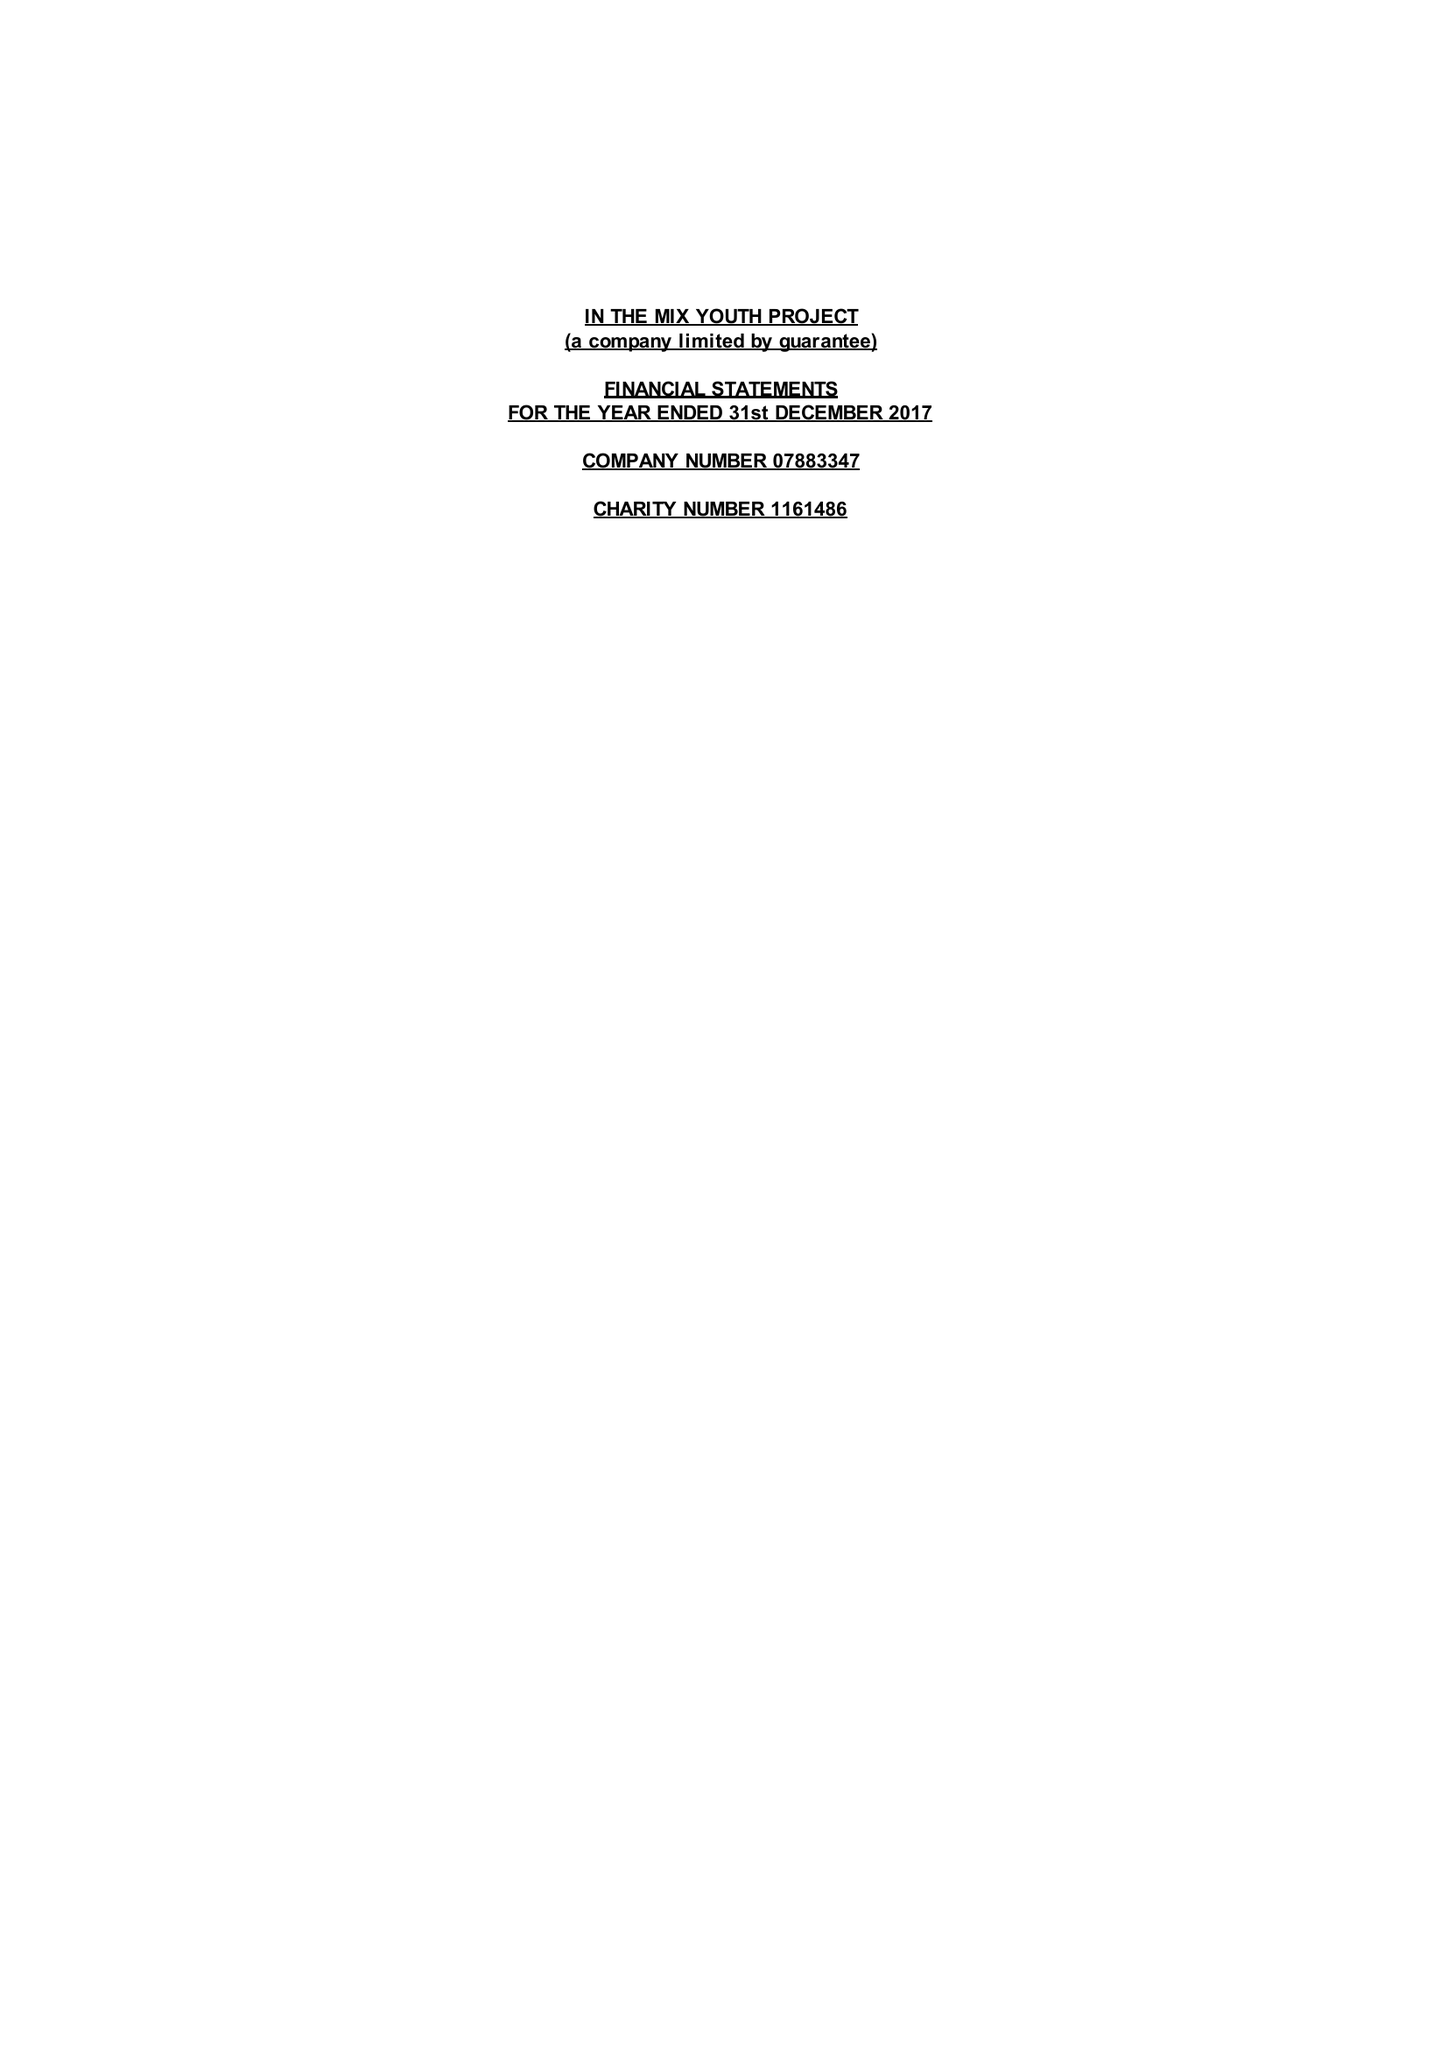What is the value for the address__post_town?
Answer the question using a single word or phrase. TAUNTON 